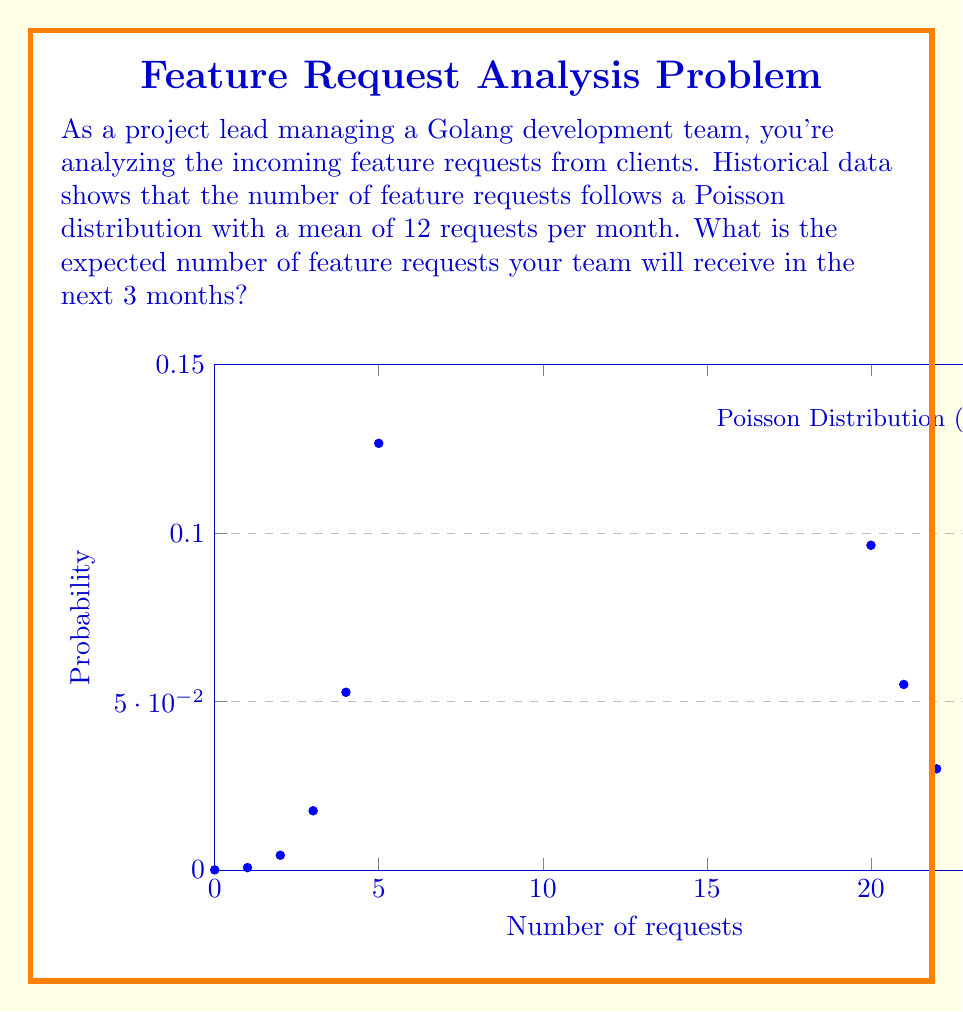Solve this math problem. To solve this problem, we'll use the properties of the Poisson distribution and linearity of expectation:

1) The Poisson distribution has the property that its expected value (mean) is equal to its parameter $\lambda$. In this case, $\lambda = 12$ requests per month.

2) We're asked about the expected number of requests over 3 months. Let's call the random variable for the number of requests in 3 months $X$.

3) The number of requests in each month can be considered independent Poisson processes. The sum of independent Poisson processes is also a Poisson process, with the parameter being the sum of the individual parameters.

4) Therefore, for 3 months, the parameter of the Poisson distribution will be:

   $\lambda_{3\text{ months}} = 12 + 12 + 12 = 3 \times 12 = 36$

5) The expected value of a Poisson distribution is equal to its parameter. Thus:

   $E[X] = \lambda_{3\text{ months}} = 36$

Therefore, the expected number of feature requests in 3 months is 36.
Answer: 36 requests 